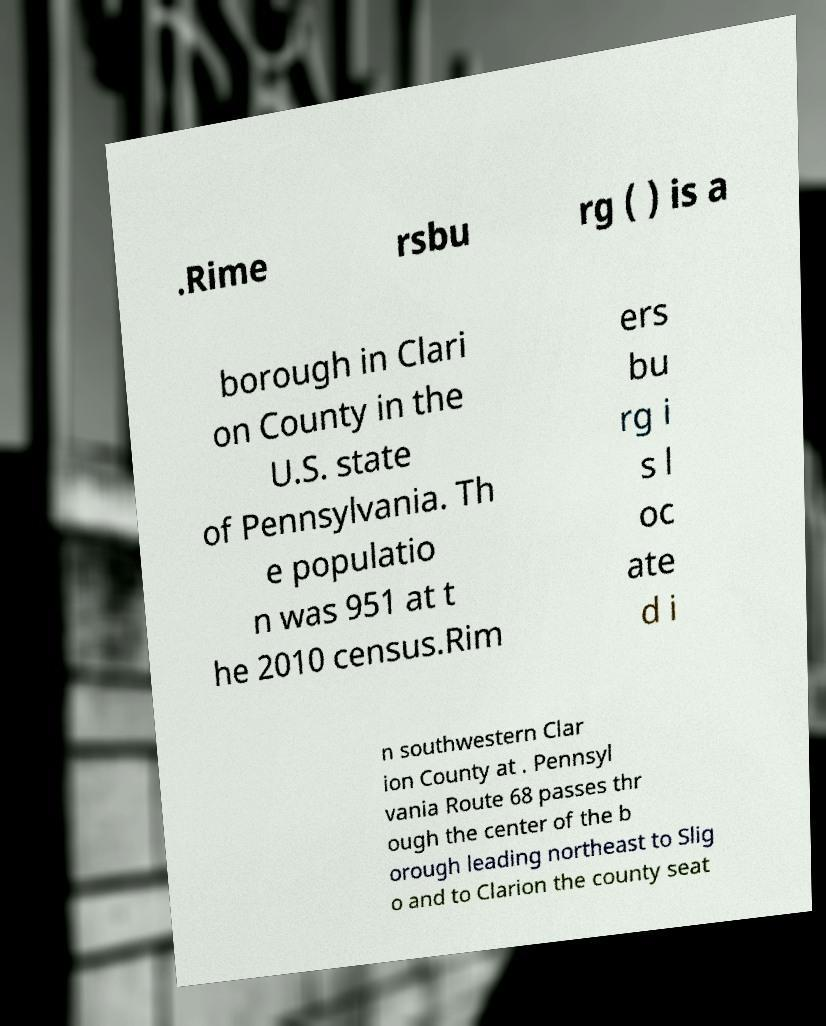Please read and relay the text visible in this image. What does it say? .Rime rsbu rg ( ) is a borough in Clari on County in the U.S. state of Pennsylvania. Th e populatio n was 951 at t he 2010 census.Rim ers bu rg i s l oc ate d i n southwestern Clar ion County at . Pennsyl vania Route 68 passes thr ough the center of the b orough leading northeast to Slig o and to Clarion the county seat 